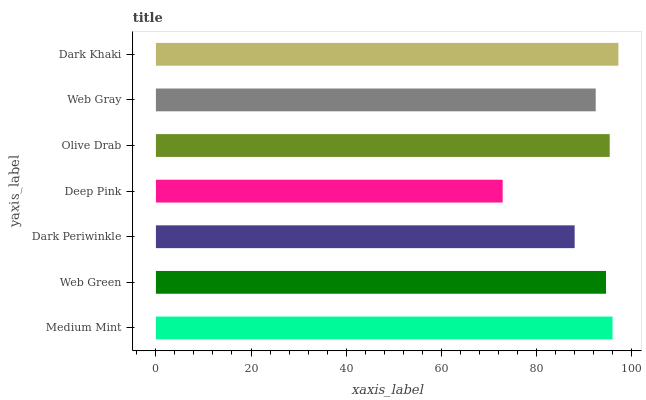Is Deep Pink the minimum?
Answer yes or no. Yes. Is Dark Khaki the maximum?
Answer yes or no. Yes. Is Web Green the minimum?
Answer yes or no. No. Is Web Green the maximum?
Answer yes or no. No. Is Medium Mint greater than Web Green?
Answer yes or no. Yes. Is Web Green less than Medium Mint?
Answer yes or no. Yes. Is Web Green greater than Medium Mint?
Answer yes or no. No. Is Medium Mint less than Web Green?
Answer yes or no. No. Is Web Green the high median?
Answer yes or no. Yes. Is Web Green the low median?
Answer yes or no. Yes. Is Medium Mint the high median?
Answer yes or no. No. Is Olive Drab the low median?
Answer yes or no. No. 